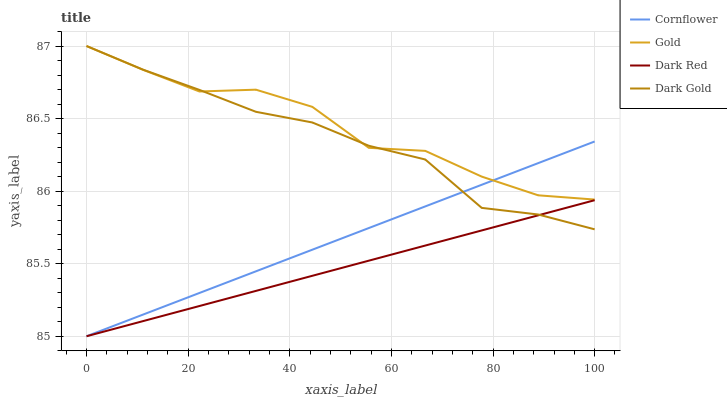Does Dark Red have the minimum area under the curve?
Answer yes or no. Yes. Does Gold have the maximum area under the curve?
Answer yes or no. Yes. Does Dark Gold have the minimum area under the curve?
Answer yes or no. No. Does Dark Gold have the maximum area under the curve?
Answer yes or no. No. Is Dark Red the smoothest?
Answer yes or no. Yes. Is Gold the roughest?
Answer yes or no. Yes. Is Dark Gold the smoothest?
Answer yes or no. No. Is Dark Gold the roughest?
Answer yes or no. No. Does Cornflower have the lowest value?
Answer yes or no. Yes. Does Dark Gold have the lowest value?
Answer yes or no. No. Does Gold have the highest value?
Answer yes or no. Yes. Does Dark Red have the highest value?
Answer yes or no. No. Is Dark Red less than Gold?
Answer yes or no. Yes. Is Gold greater than Dark Red?
Answer yes or no. Yes. Does Dark Gold intersect Dark Red?
Answer yes or no. Yes. Is Dark Gold less than Dark Red?
Answer yes or no. No. Is Dark Gold greater than Dark Red?
Answer yes or no. No. Does Dark Red intersect Gold?
Answer yes or no. No. 